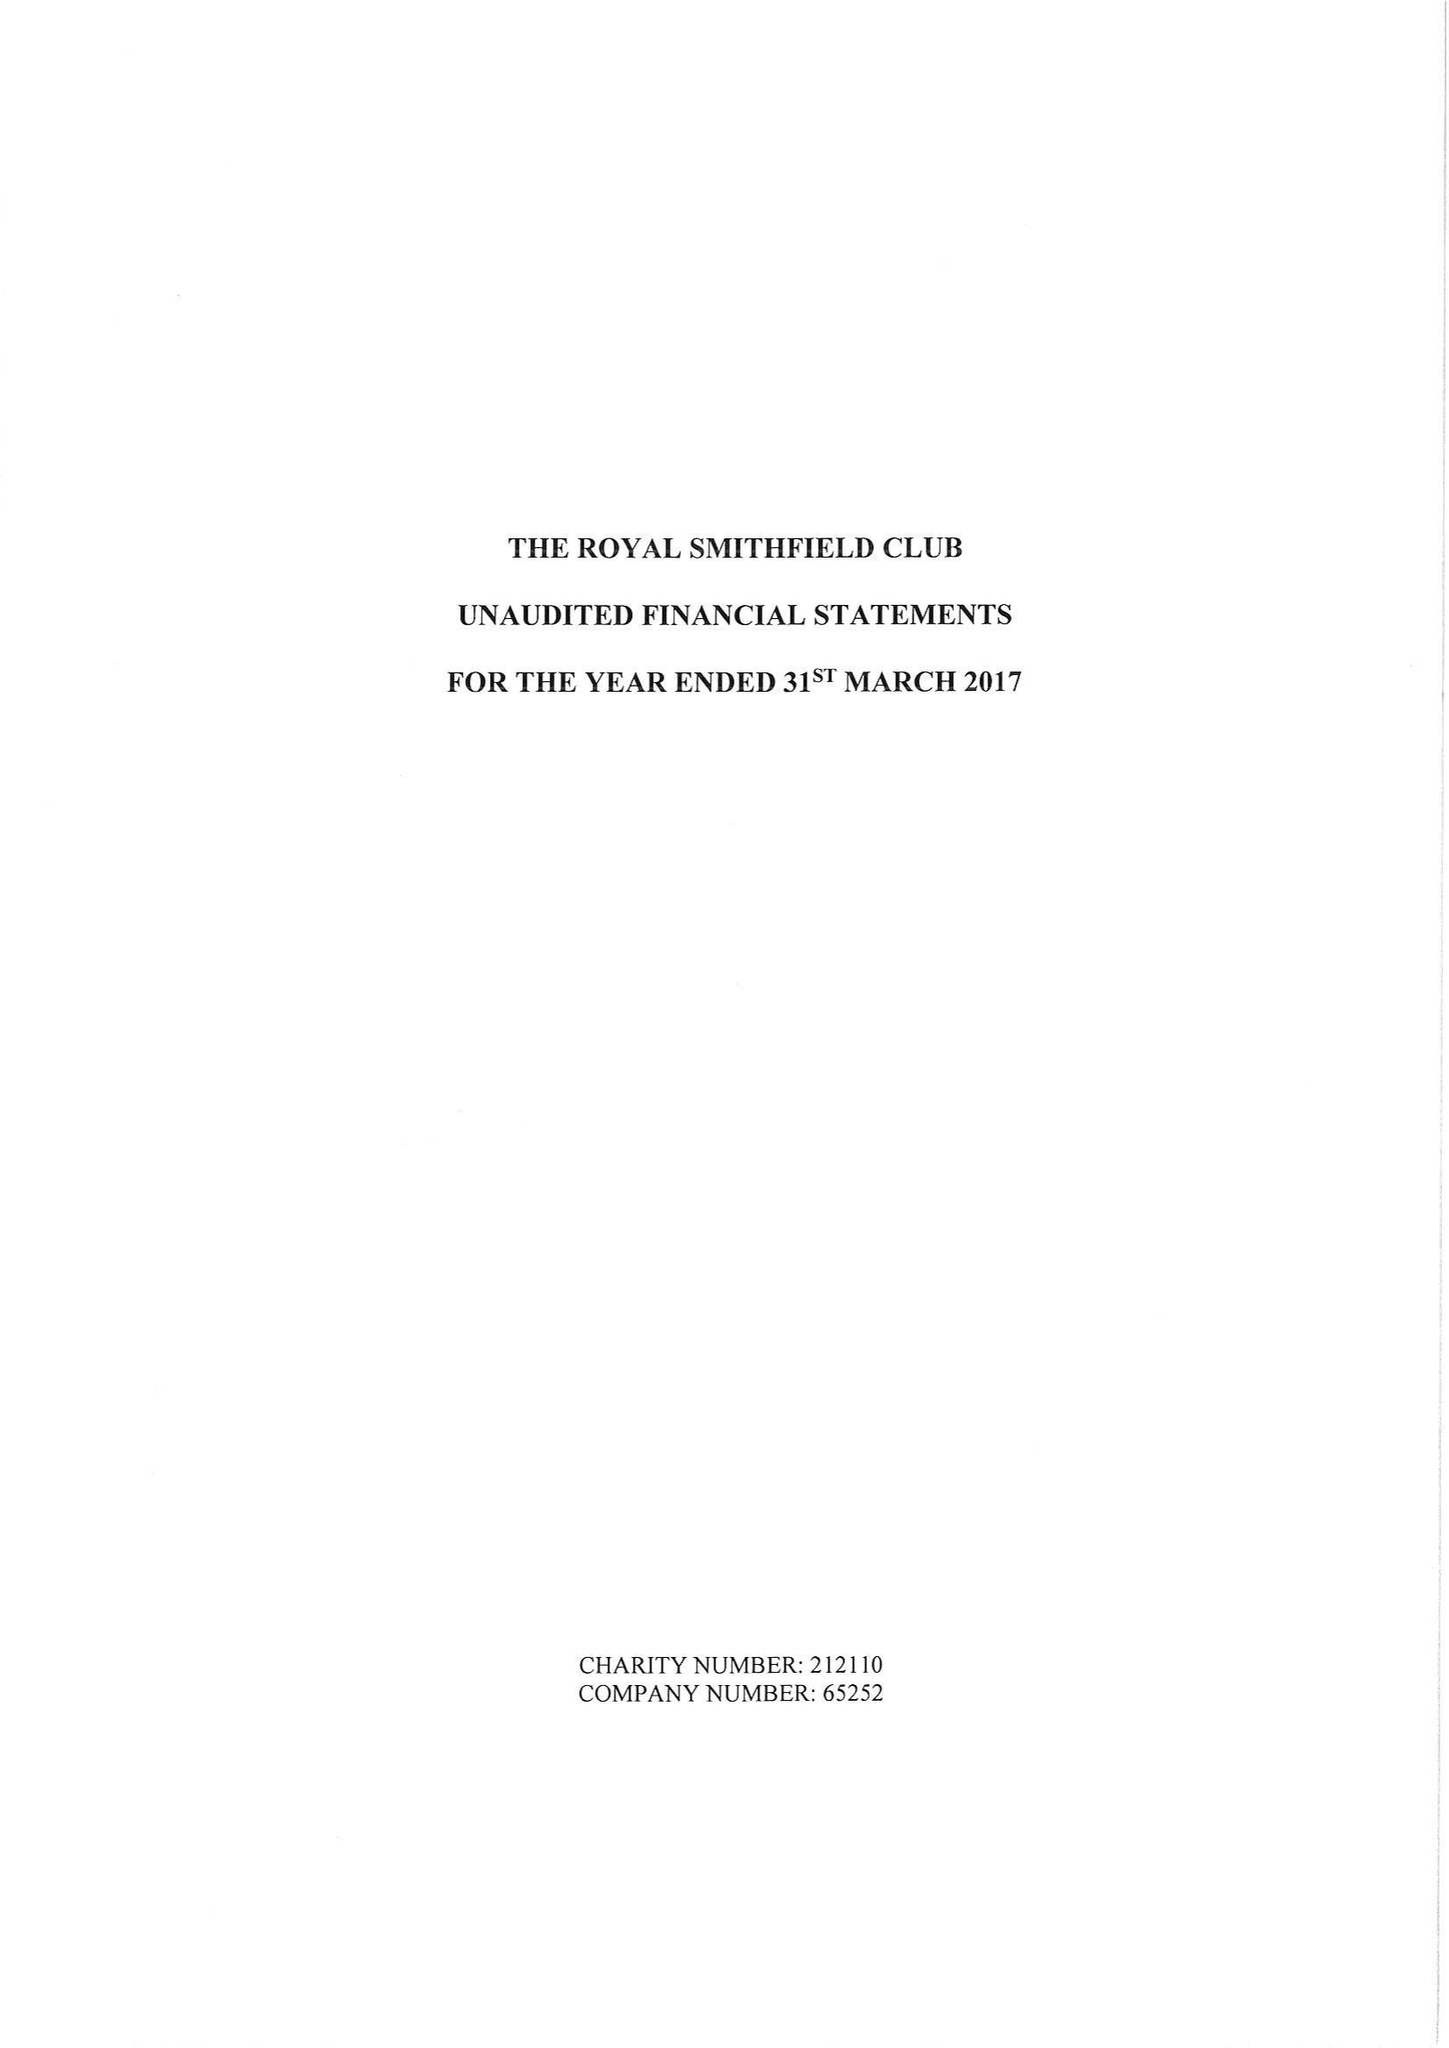What is the value for the report_date?
Answer the question using a single word or phrase. 2017-03-31 